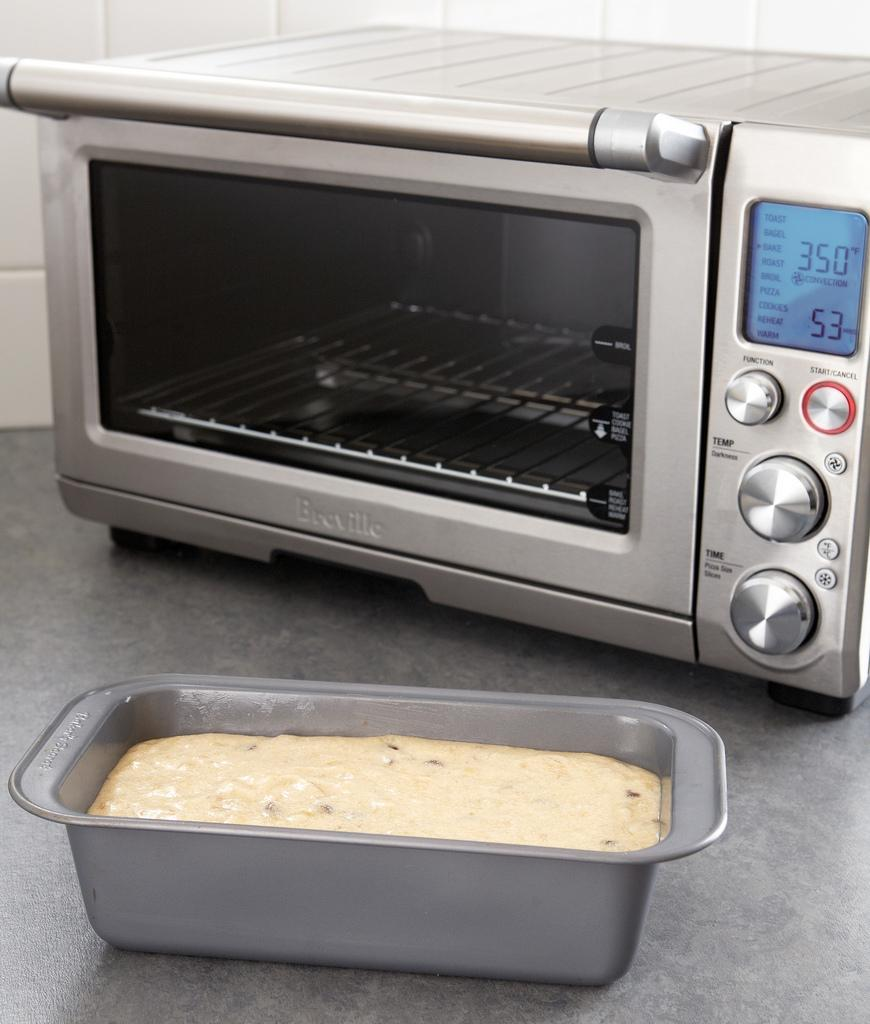<image>
Offer a succinct explanation of the picture presented. Small silver toaster oven that is made by Breville 